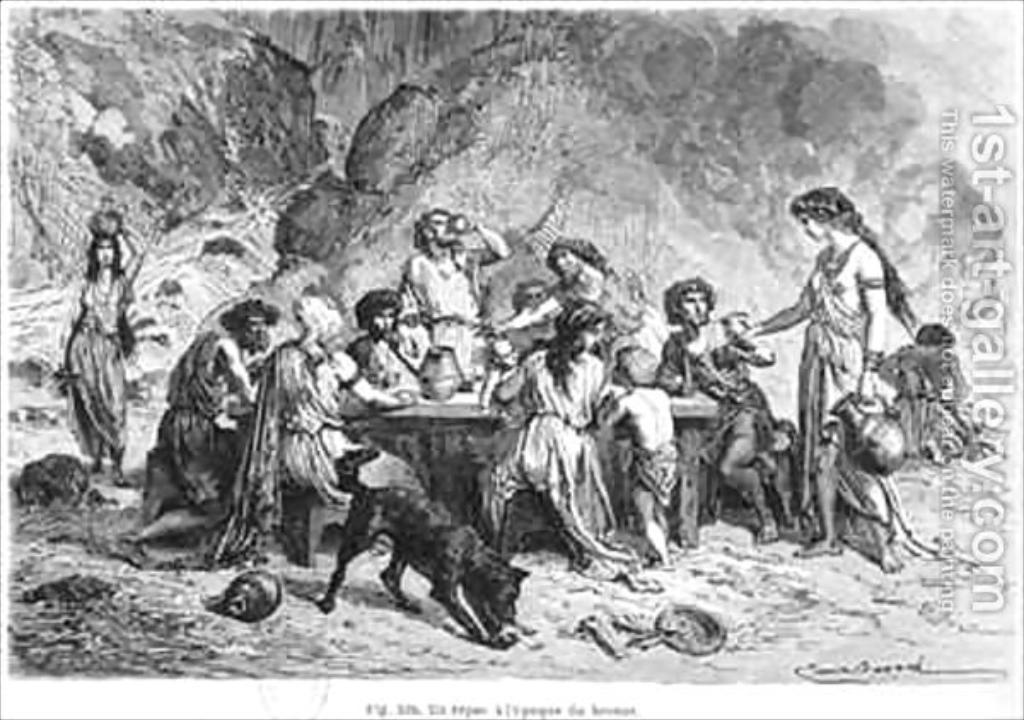Please provide a concise description of this image. In this picture we can see an object which seems to be the poster on which we can see the pictures. In the center we can see the group of people seems to be sitting. On the right there is a person holding some object and standing on the ground. On the left we can see a person holding an object and walking on the ground and we can see an animal seems to be eating something and there are some objects lying on the ground. In the background we can see some other items and we can see the text on the image. 